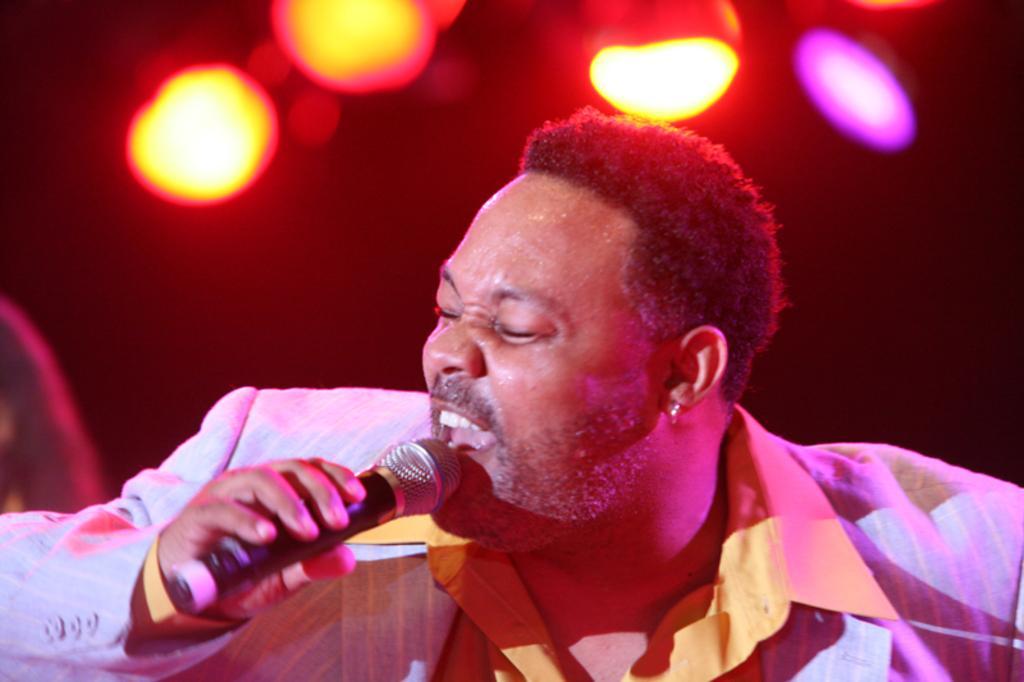How would you summarize this image in a sentence or two? In the picture I can see a man and he is singing on a microphone. He is wearing a shirt and a suit. These are looking like a decorative lights at the top of the picture. 